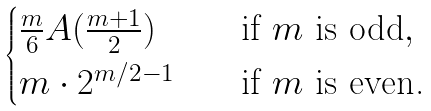Convert formula to latex. <formula><loc_0><loc_0><loc_500><loc_500>\begin{cases} \frac { m } { 6 } A ( \frac { m + 1 } { 2 } ) \quad & \text {if $m$ is odd} , \\ m \cdot 2 ^ { m / 2 - 1 } \quad & \text {if $m$ is even.} \end{cases}</formula> 